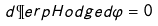<formula> <loc_0><loc_0><loc_500><loc_500>d \P e r p H o d g e d \varphi = 0</formula> 